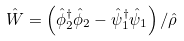Convert formula to latex. <formula><loc_0><loc_0><loc_500><loc_500>\hat { W } = \left ( \hat { \phi } _ { 2 } ^ { \dagger } \hat { \phi } _ { 2 } - \hat { \psi } _ { 1 } ^ { \dagger } \hat { \psi } _ { 1 } \right ) / \hat { \rho }</formula> 